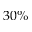Convert formula to latex. <formula><loc_0><loc_0><loc_500><loc_500>3 0 \%</formula> 